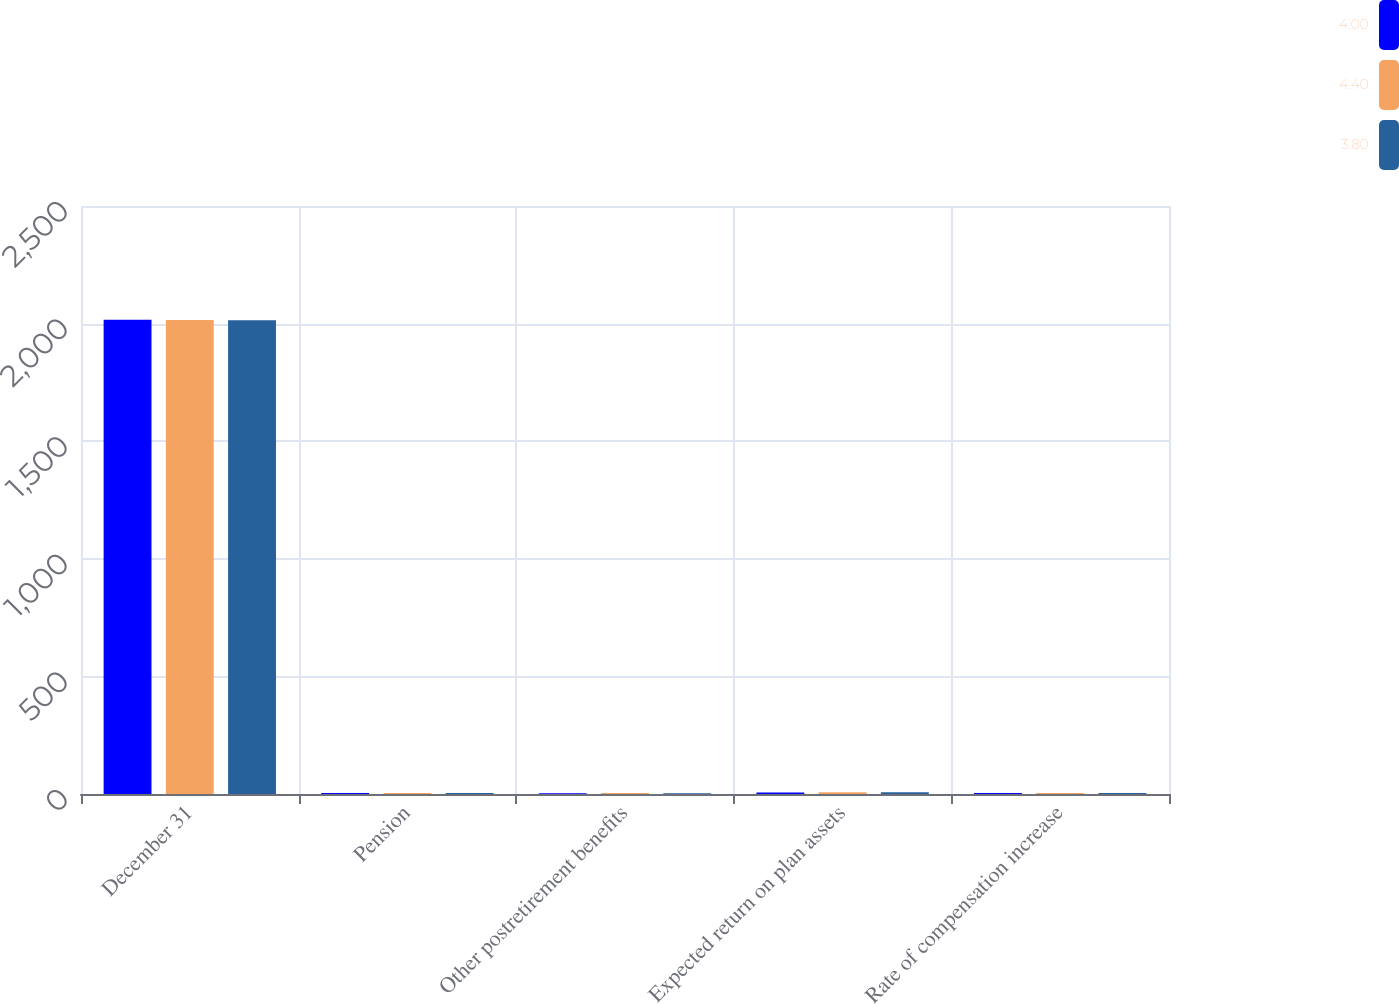<chart> <loc_0><loc_0><loc_500><loc_500><stacked_bar_chart><ecel><fcel>December 31<fcel>Pension<fcel>Other postretirement benefits<fcel>Expected return on plan assets<fcel>Rate of compensation increase<nl><fcel>4<fcel>2016<fcel>4<fcel>3.7<fcel>6.8<fcel>4.4<nl><fcel>4.4<fcel>2015<fcel>4.2<fcel>3.8<fcel>7<fcel>4<nl><fcel>3.8<fcel>2014<fcel>3.9<fcel>3.5<fcel>7<fcel>3.8<nl></chart> 